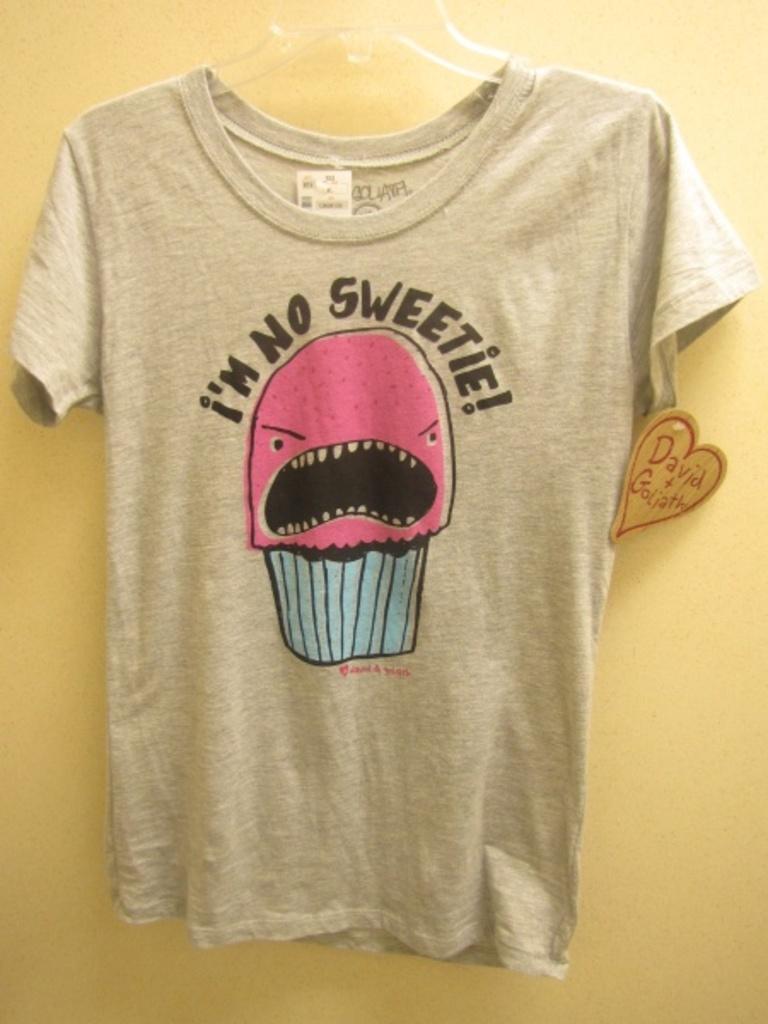Please provide a concise description of this image. In this image I can see the shirt hanged to the wall. The shirt is in ash color. On the shirt there is a text i'm no sweetie is written on that. And the wall is in yellow color. 